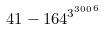<formula> <loc_0><loc_0><loc_500><loc_500>4 1 - 1 6 4 ^ { { 3 ^ { 3 0 0 } } ^ { 6 } }</formula> 